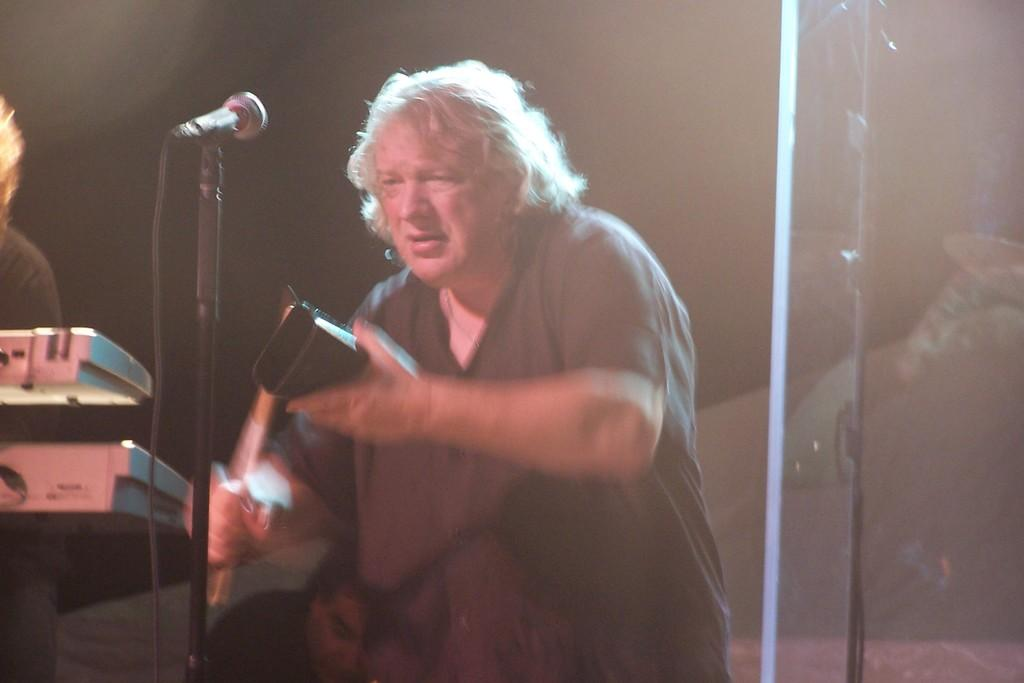What is the main subject of the image? There is a person standing in the image. What object is located on the left side of the image? There is a microphone on the left side of the image. Can you describe the background of the image? The background of the image is dark. What type of silver object is being smashed by the person in the image? There is no silver object being smashed in the image; the person is simply standing with a microphone on the left side. How is the person transporting the microphone in the image? The person is not transporting the microphone in the image; it is stationary on the left side. 